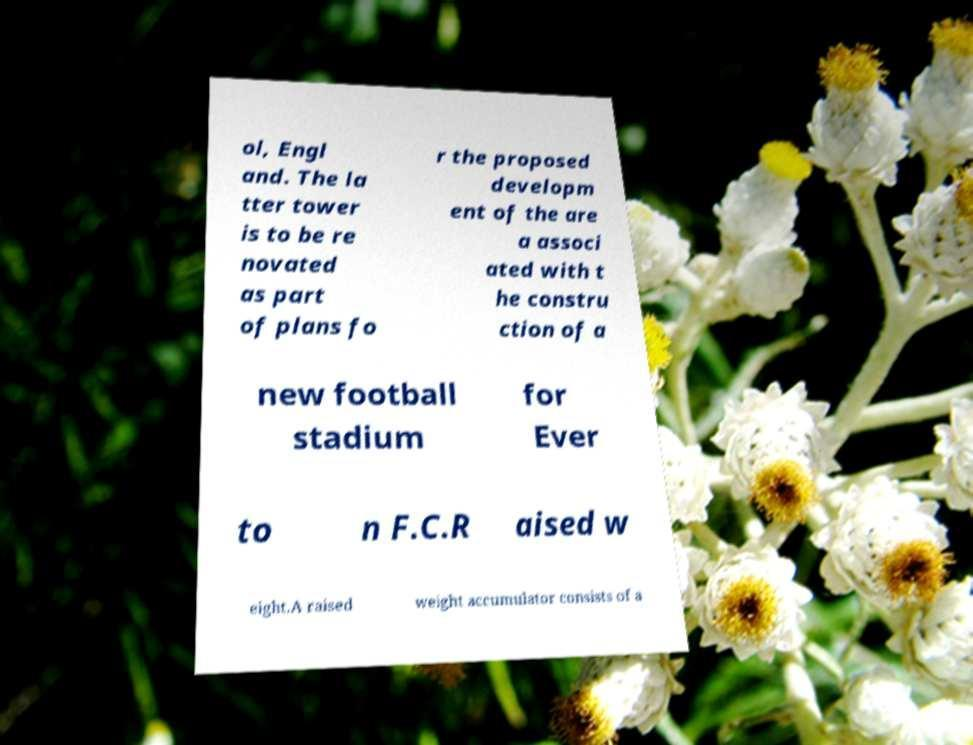Could you extract and type out the text from this image? ol, Engl and. The la tter tower is to be re novated as part of plans fo r the proposed developm ent of the are a associ ated with t he constru ction of a new football stadium for Ever to n F.C.R aised w eight.A raised weight accumulator consists of a 